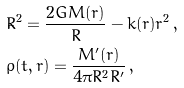<formula> <loc_0><loc_0><loc_500><loc_500>& { \dot { R } } ^ { 2 } = \frac { 2 G M ( r ) } { R } - k ( r ) r ^ { 2 } \, , \\ & \rho ( t , r ) = \frac { M ^ { \prime } ( r ) } { 4 \pi R ^ { 2 } R ^ { \prime } } \, ,</formula> 